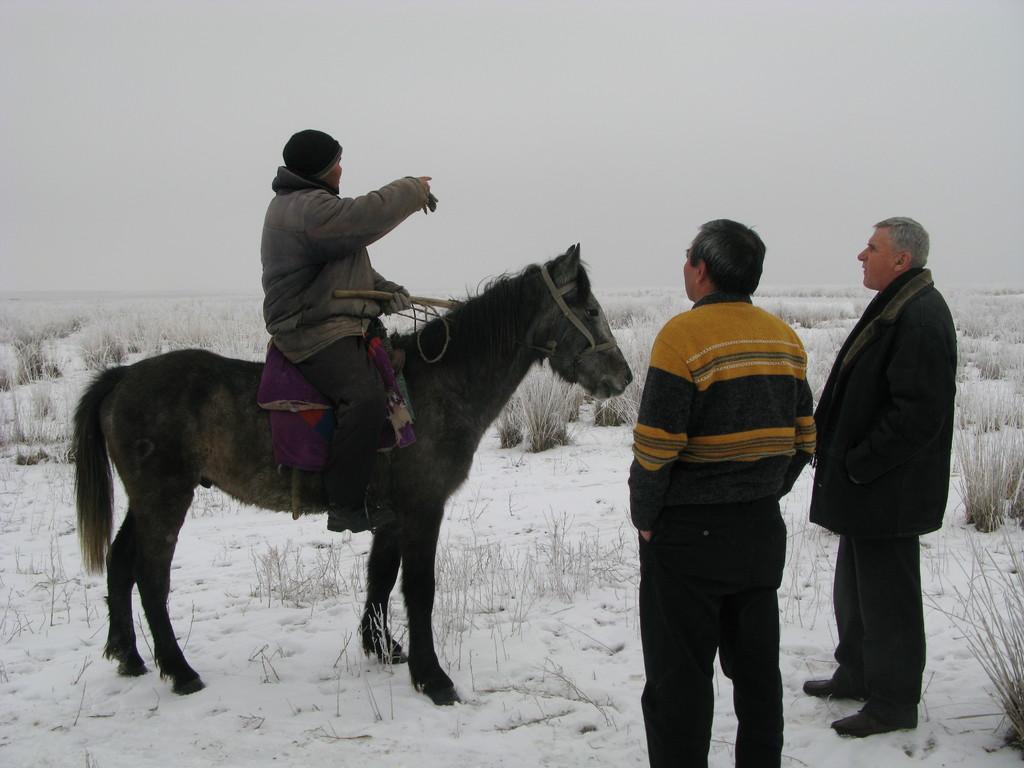In one or two sentences, can you explain what this image depicts? Here we see three men a man riding a horse other two are standing. 